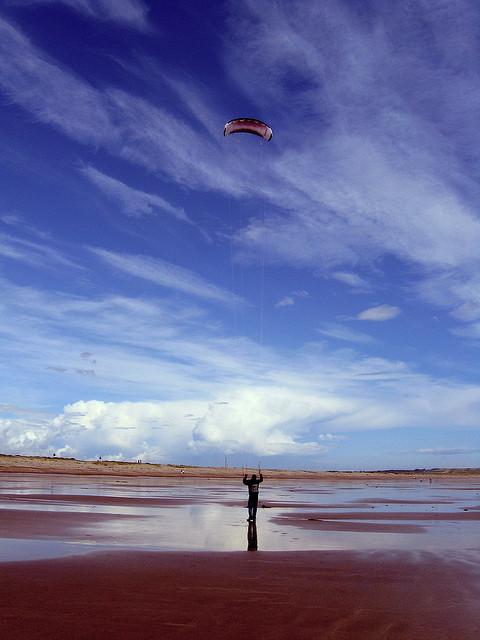What are they flying?
Keep it brief. Kite. What type of clouds make up the background?
Concise answer only. Cirrus. Is the ground wet from rain?
Short answer required. Yes. Is the sky clear?
Short answer required. No. Is she walking on water?
Be succinct. No. 